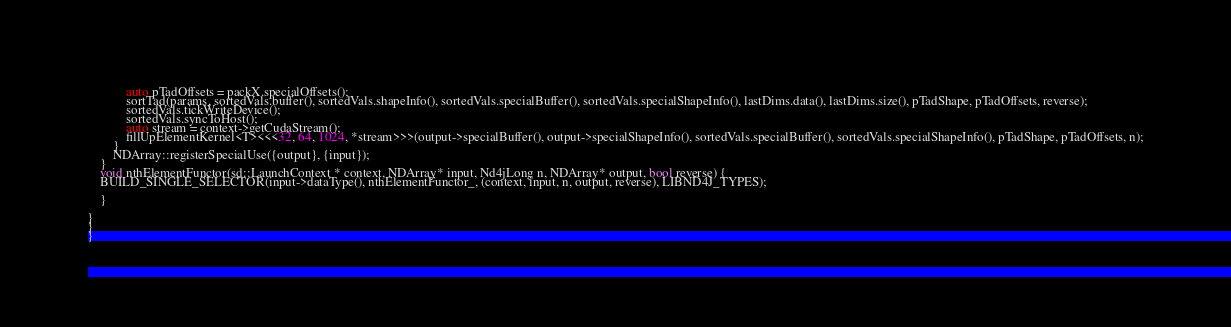<code> <loc_0><loc_0><loc_500><loc_500><_Cuda_>            auto pTadOffsets = packX.specialOffsets();
            sortTad(params, sortedVals.buffer(), sortedVals.shapeInfo(), sortedVals.specialBuffer(), sortedVals.specialShapeInfo(), lastDims.data(), lastDims.size(), pTadShape, pTadOffsets, reverse);
            sortedVals.tickWriteDevice();
            sortedVals.syncToHost();
            auto stream = context->getCudaStream();
            fillUpElementKernel<T><<<32, 64, 1024, *stream>>>(output->specialBuffer(), output->specialShapeInfo(), sortedVals.specialBuffer(), sortedVals.specialShapeInfo(), pTadShape, pTadOffsets, n);
        }
        NDArray::registerSpecialUse({output}, {input});
    }
    void nthElementFunctor(sd::LaunchContext * context, NDArray* input, Nd4jLong n, NDArray* output, bool reverse) {
    BUILD_SINGLE_SELECTOR(input->dataType(), nthElementFunctor_, (context, input, n, output, reverse), LIBND4J_TYPES);

    }

}
}
}
</code> 